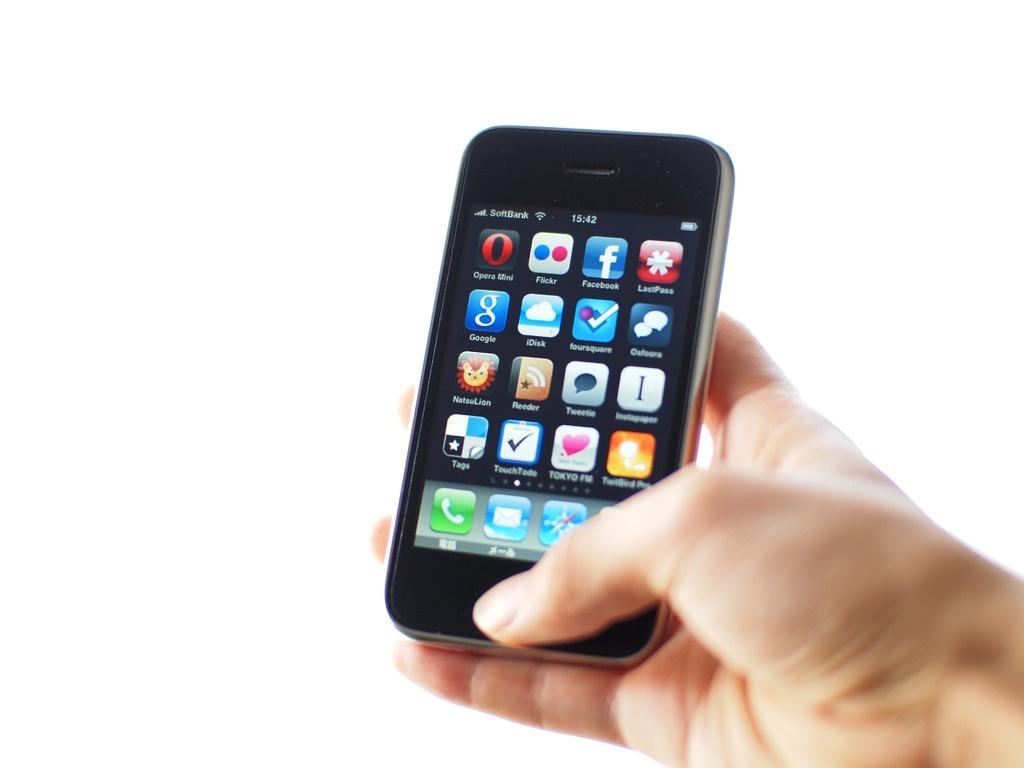Provide a one-sentence caption for the provided image. A female hand is holding a black cell phone with many apps on the screen, including google and Flickr. 